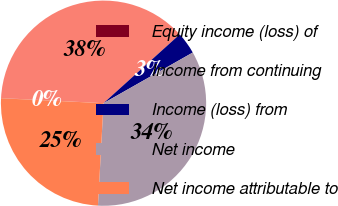Convert chart. <chart><loc_0><loc_0><loc_500><loc_500><pie_chart><fcel>Equity income (loss) of<fcel>Income from continuing<fcel>Income (loss) from<fcel>Net income<fcel>Net income attributable to<nl><fcel>0.03%<fcel>37.52%<fcel>3.47%<fcel>34.08%<fcel>24.9%<nl></chart> 